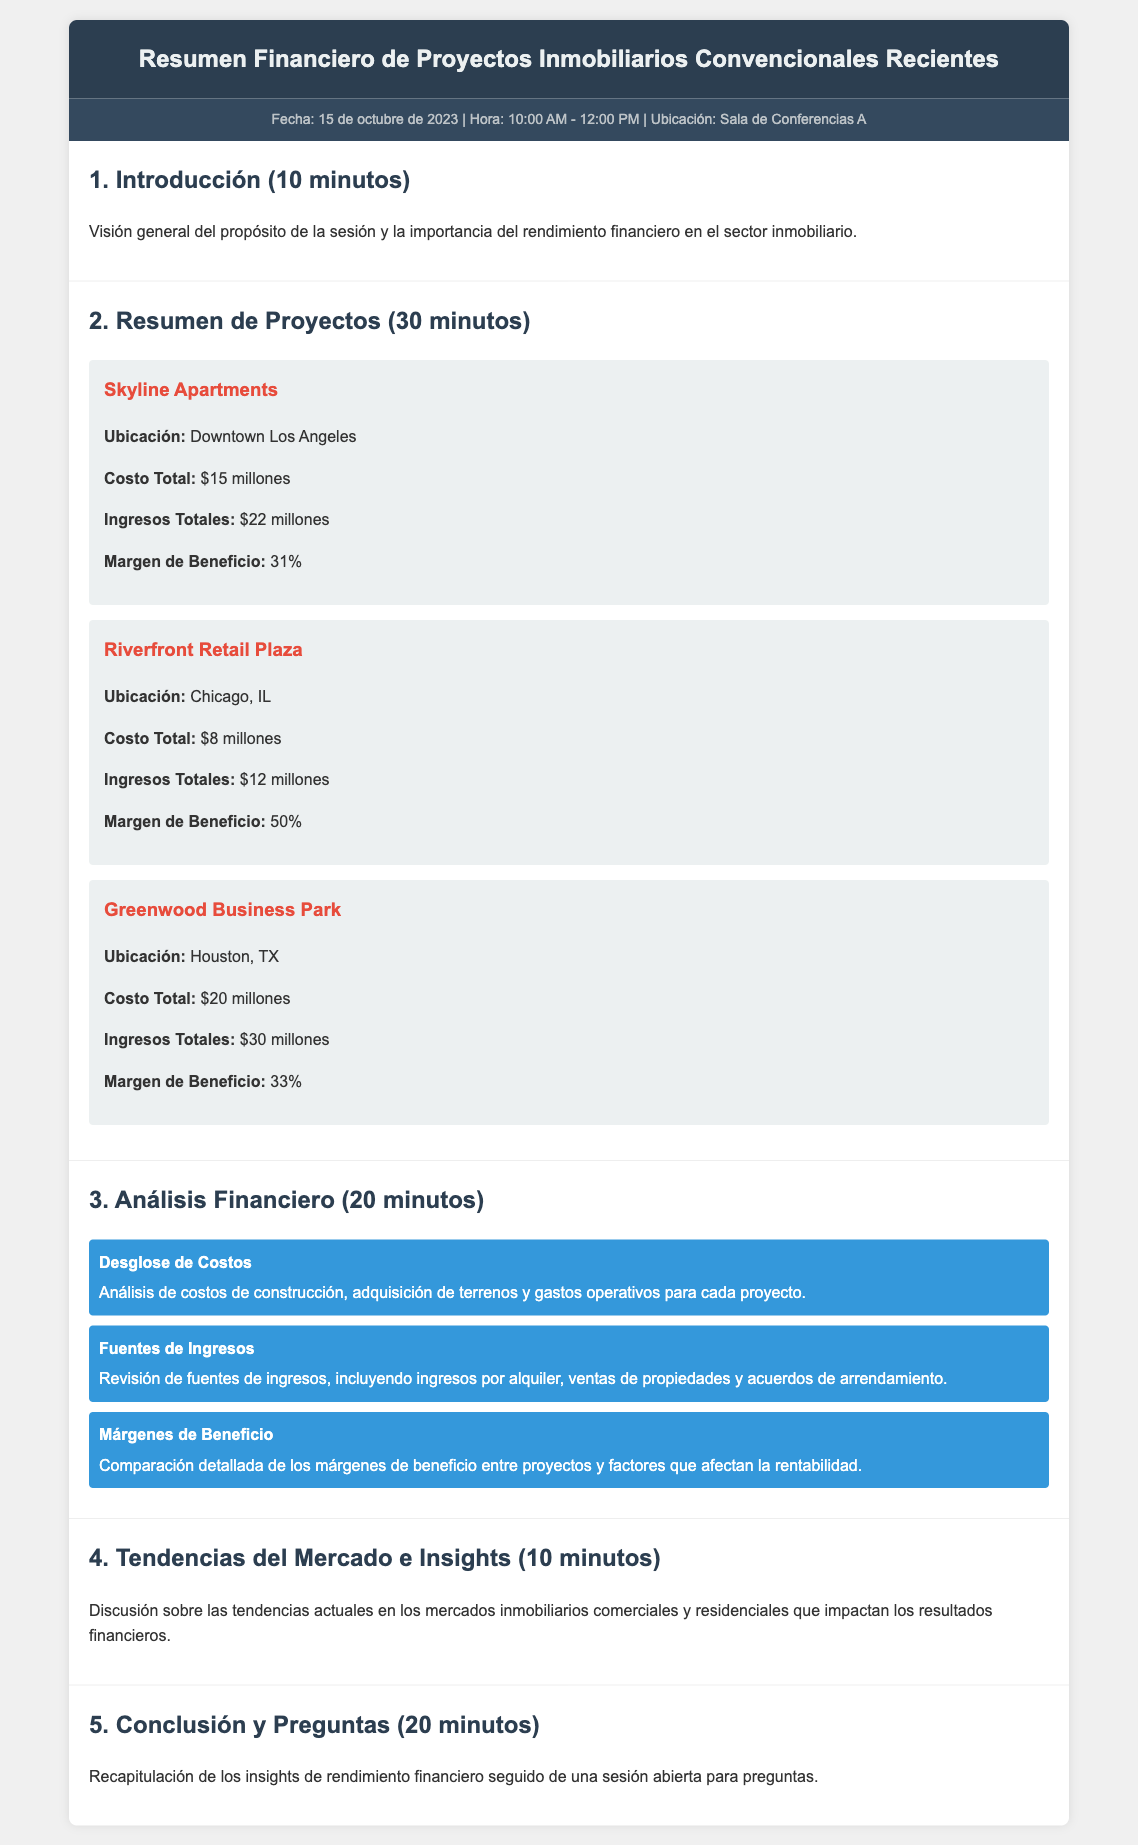¿Cuál es la fecha de la reunión? La fecha de la reunión se menciona en la sección de meta-información del documento.
Answer: 15 de octubre de 2023 ¿Cuál es el margen de beneficio de los Skyline Apartments? El margen de beneficio se encuentra dentro de la descripción del proyecto Skyline Apartments.
Answer: 31% ¿Cuál es el costo total del proyecto Riverfront Retail Plaza? El costo total se menciona claramente en la sección correspondiente al proyecto Riverfront Retail Plaza.
Answer: $8 millones ¿Qué ubicación tiene el proyecto Greenwood Business Park? La ubicación está especificada en la descripción del proyecto Greenwood Business Park.
Answer: Houston, TX ¿Cuáles son las fuentes de ingresos discutidas en el análisis financiero? Las fuentes de ingresos son mencionadas en una de las secciones del análisis financiero.
Answer: Ingresos por alquiler, ventas de propiedades y acuerdos de arrendamiento ¿Cuánto tiempo se dedicará a la sección de introducción? El tiempo total dedicado a la sección de introducción se indica en el encabezado de la sección.
Answer: 10 minutos ¿Cuál es el total de ingresos del proyecto Skyline Apartments? El total de ingresos se proporciona dentro de los detalles del proyecto Skyline Apartments.
Answer: $22 millones ¿Cuántos minutos están destinados a la conclusión y preguntas? La duración de la sección de conclusión y preguntas se detalla en el encabezado de esa sección.
Answer: 20 minutos 